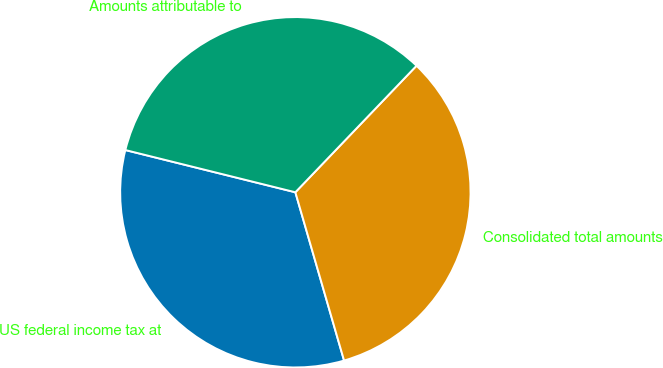<chart> <loc_0><loc_0><loc_500><loc_500><pie_chart><fcel>US federal income tax at<fcel>Consolidated total amounts<fcel>Amounts attributable to<nl><fcel>33.36%<fcel>33.36%<fcel>33.28%<nl></chart> 